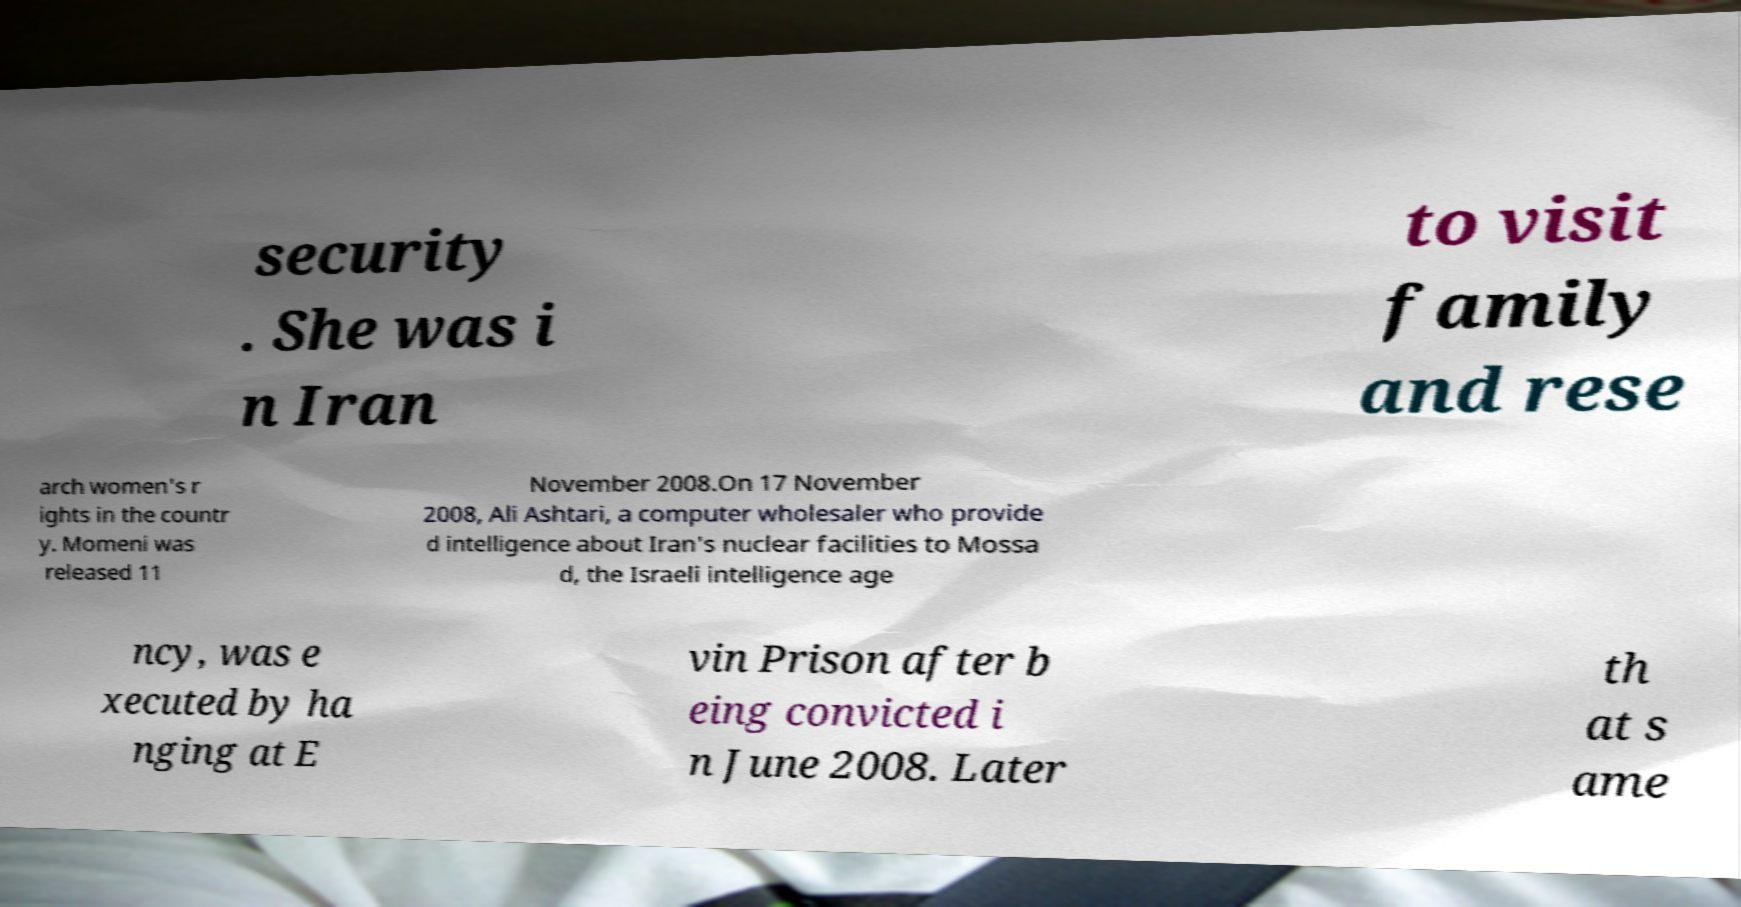Can you read and provide the text displayed in the image?This photo seems to have some interesting text. Can you extract and type it out for me? security . She was i n Iran to visit family and rese arch women's r ights in the countr y. Momeni was released 11 November 2008.On 17 November 2008, Ali Ashtari, a computer wholesaler who provide d intelligence about Iran's nuclear facilities to Mossa d, the Israeli intelligence age ncy, was e xecuted by ha nging at E vin Prison after b eing convicted i n June 2008. Later th at s ame 